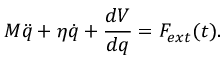Convert formula to latex. <formula><loc_0><loc_0><loc_500><loc_500>M \ddot { q } + \eta \dot { q } + \frac { d V } { d q } = F _ { e x t } ( t ) .</formula> 